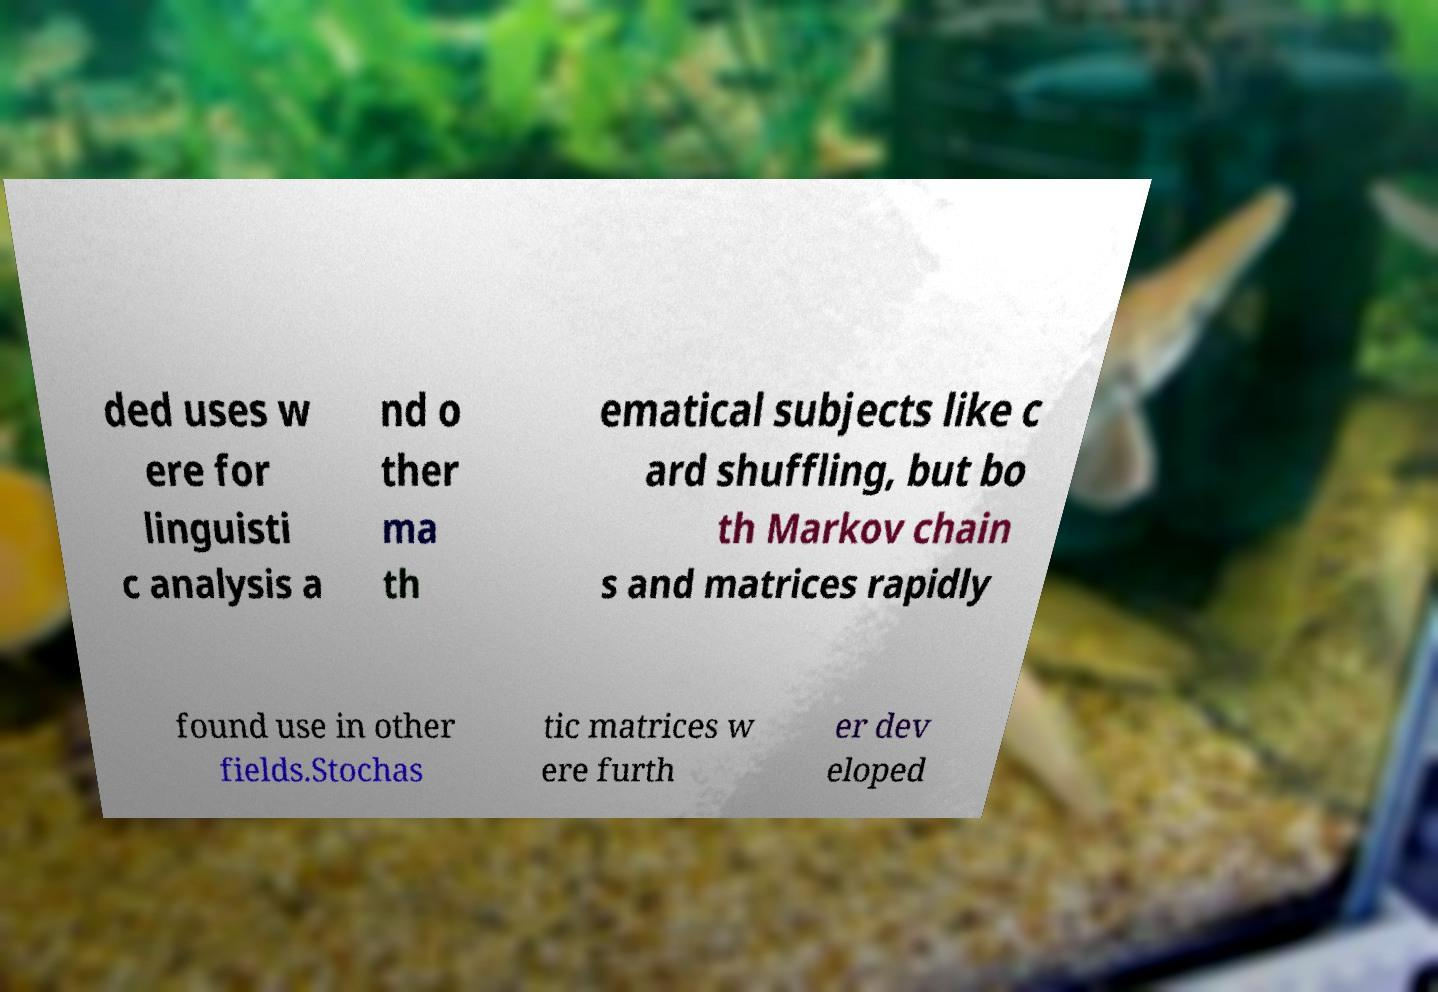Please read and relay the text visible in this image. What does it say? ded uses w ere for linguisti c analysis a nd o ther ma th ematical subjects like c ard shuffling, but bo th Markov chain s and matrices rapidly found use in other fields.Stochas tic matrices w ere furth er dev eloped 